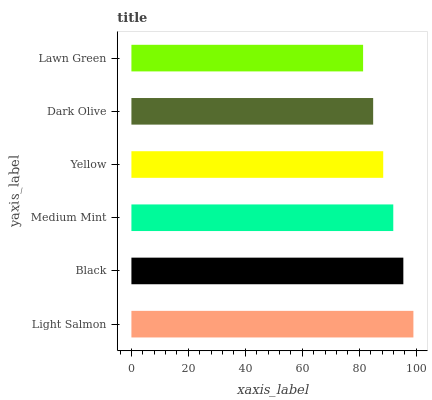Is Lawn Green the minimum?
Answer yes or no. Yes. Is Light Salmon the maximum?
Answer yes or no. Yes. Is Black the minimum?
Answer yes or no. No. Is Black the maximum?
Answer yes or no. No. Is Light Salmon greater than Black?
Answer yes or no. Yes. Is Black less than Light Salmon?
Answer yes or no. Yes. Is Black greater than Light Salmon?
Answer yes or no. No. Is Light Salmon less than Black?
Answer yes or no. No. Is Medium Mint the high median?
Answer yes or no. Yes. Is Yellow the low median?
Answer yes or no. Yes. Is Yellow the high median?
Answer yes or no. No. Is Medium Mint the low median?
Answer yes or no. No. 